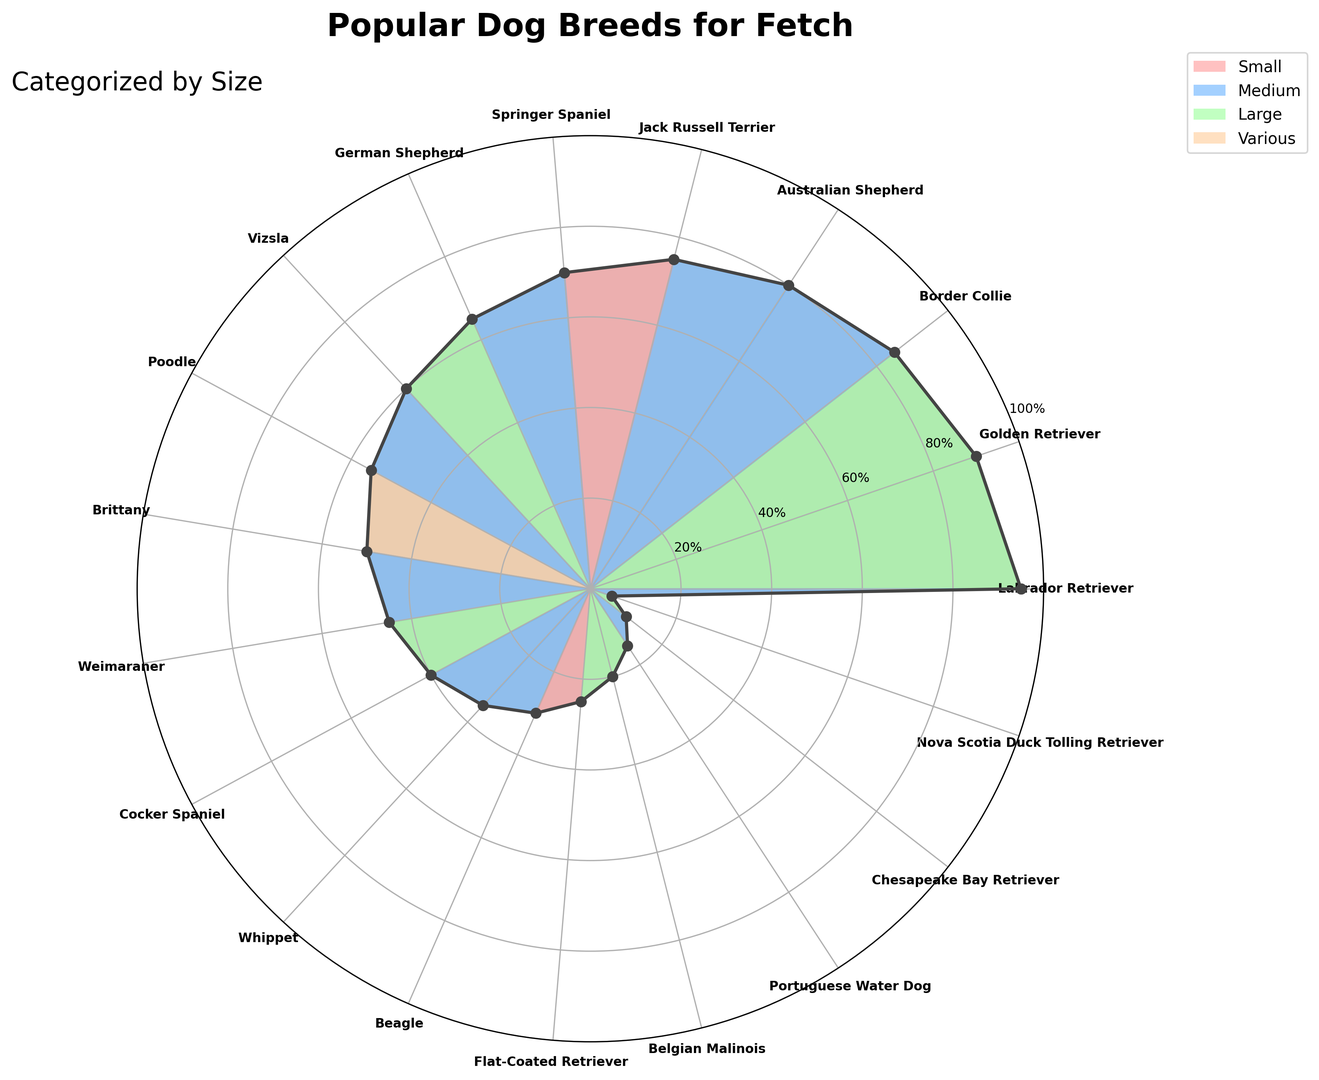Which dog breed is the most popular for fetch? The breed at the highest point on the rose chart represents the most popular breed for fetch. This breed is the Labrador Retriever.
Answer: Labrador Retriever Which dog breed has the lowest fetch popularity? The breed at the lowest point on the rose chart represents the least popular breed for fetch. This breed is the Nova Scotia Duck Tolling Retriever.
Answer: Nova Scotia Duck Tolling Retriever How many breeds fall into the "Medium" size category, and what is their average fetch popularity? Count the number of breeds marked with the color representing "Medium" size. These are Border Collie, Australian Shepherd, Springer Spaniel, Vizsla, Brittany, Cocker Spaniel, Whippet, and Nova Scotia Duck Tolling Retriever. Their fetch popularity values are 85, 80, 70, 60, 50, 40, 35, and 5 respectively. Sum them up and divide by the count (8). Average = (85 + 80 + 70 + 60 + 50 + 40 + 35 + 5) / 8 = 53.125
Answer: 53.125 Which breed has a higher fetch popularity, German Shepherd or Whippet? Compare the heights of the line segment corresponding to the German Shepherd and the Whippet. The German Shepherd has a fetch popularity of 65, whereas the Whippet has 35. Therefore, the German Shepherd has a higher fetch popularity.
Answer: German Shepherd What is the difference in fetch popularity between the highest and the lowest dog breeds? The highest fetch popularity is for the Labrador Retriever at 95, and the lowest for the Nova Scotia Duck Tolling Retriever at 5. The difference is 95 - 5 = 90.
Answer: 90 How many breeds are in the "Large" category? Count the number of segments filled with the color representing "Large" size in the rose chart. These breeds are Labrador Retriever, Golden Retriever, German Shepherd, Weimaraner, Flat-Coated Retriever, Belgian Malinois, and Chesapeake Bay Retriever. So, there are 7 breeds.
Answer: 7 What's the total fetch popularity score for all the "Small" sized dog breeds? Add the fetch popularity values of the breeds marked with the color representing "Small" size, which are Jack Russell Terrier (fetch popularity 75) and Beagle (fetch popularity 30). Sum = 75 + 30 = 105
Answer: 105 Which medium-sized breed has the highest fetch popularity, and what is its value? Among the breeds with the color representing "Medium" size, the Border Collie has the highest position, indicating it has the highest fetch popularity at 85.
Answer: Border Collie, 85 